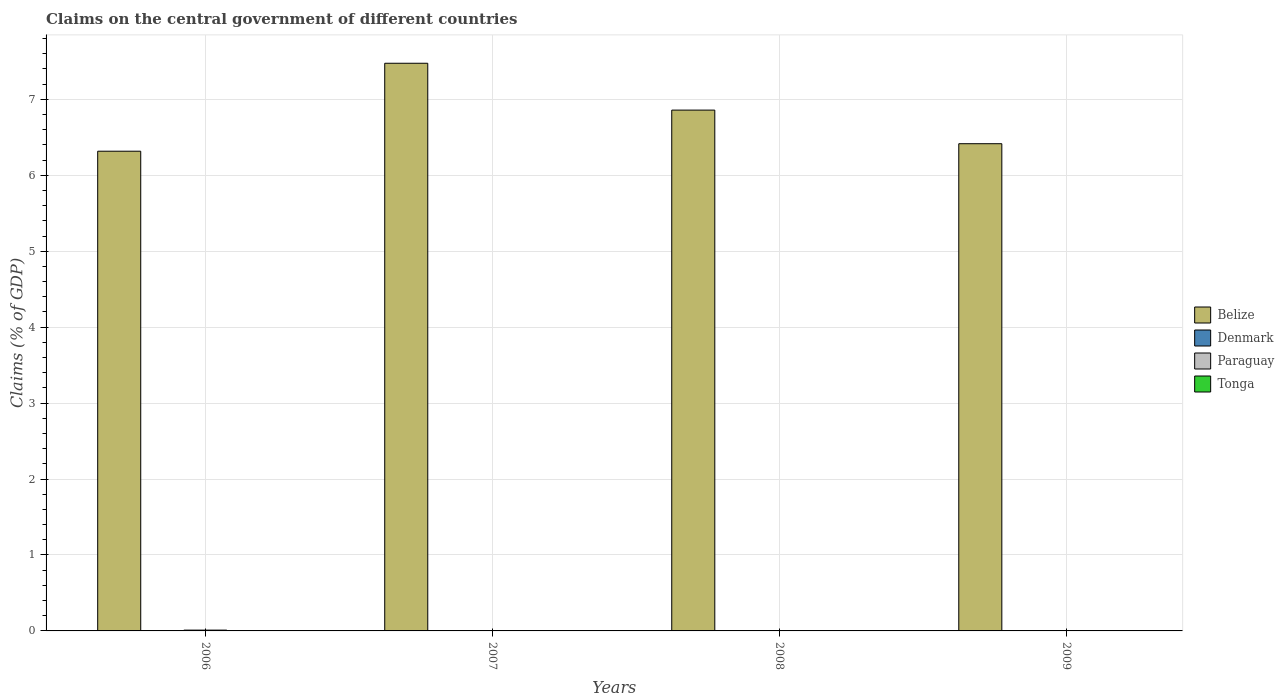Are the number of bars per tick equal to the number of legend labels?
Your answer should be compact. No. How many bars are there on the 3rd tick from the right?
Your answer should be very brief. 1. In how many cases, is the number of bars for a given year not equal to the number of legend labels?
Your answer should be very brief. 4. Across all years, what is the maximum percentage of GDP claimed on the central government in Paraguay?
Ensure brevity in your answer.  0.01. Across all years, what is the minimum percentage of GDP claimed on the central government in Belize?
Your response must be concise. 6.32. In which year was the percentage of GDP claimed on the central government in Paraguay maximum?
Your answer should be compact. 2006. What is the total percentage of GDP claimed on the central government in Belize in the graph?
Your response must be concise. 27.07. What is the difference between the percentage of GDP claimed on the central government in Belize in 2006 and that in 2008?
Your answer should be compact. -0.54. What is the difference between the percentage of GDP claimed on the central government in Denmark in 2008 and the percentage of GDP claimed on the central government in Belize in 2009?
Your answer should be compact. -6.42. What is the difference between the highest and the second highest percentage of GDP claimed on the central government in Belize?
Provide a succinct answer. 0.62. What is the difference between the highest and the lowest percentage of GDP claimed on the central government in Belize?
Your answer should be compact. 1.16. In how many years, is the percentage of GDP claimed on the central government in Tonga greater than the average percentage of GDP claimed on the central government in Tonga taken over all years?
Give a very brief answer. 0. Is it the case that in every year, the sum of the percentage of GDP claimed on the central government in Belize and percentage of GDP claimed on the central government in Paraguay is greater than the percentage of GDP claimed on the central government in Tonga?
Give a very brief answer. Yes. How many bars are there?
Your response must be concise. 5. How many years are there in the graph?
Give a very brief answer. 4. Are the values on the major ticks of Y-axis written in scientific E-notation?
Your response must be concise. No. Does the graph contain grids?
Your response must be concise. Yes. How are the legend labels stacked?
Offer a terse response. Vertical. What is the title of the graph?
Your answer should be very brief. Claims on the central government of different countries. What is the label or title of the Y-axis?
Your answer should be compact. Claims (% of GDP). What is the Claims (% of GDP) in Belize in 2006?
Your answer should be very brief. 6.32. What is the Claims (% of GDP) of Paraguay in 2006?
Offer a terse response. 0.01. What is the Claims (% of GDP) of Tonga in 2006?
Offer a very short reply. 0. What is the Claims (% of GDP) in Belize in 2007?
Offer a very short reply. 7.47. What is the Claims (% of GDP) in Denmark in 2007?
Ensure brevity in your answer.  0. What is the Claims (% of GDP) in Tonga in 2007?
Provide a short and direct response. 0. What is the Claims (% of GDP) of Belize in 2008?
Your answer should be very brief. 6.86. What is the Claims (% of GDP) of Paraguay in 2008?
Your response must be concise. 0. What is the Claims (% of GDP) in Belize in 2009?
Offer a very short reply. 6.42. What is the Claims (% of GDP) of Denmark in 2009?
Ensure brevity in your answer.  0. What is the Claims (% of GDP) in Tonga in 2009?
Give a very brief answer. 0. Across all years, what is the maximum Claims (% of GDP) of Belize?
Your answer should be very brief. 7.47. Across all years, what is the maximum Claims (% of GDP) of Paraguay?
Provide a short and direct response. 0.01. Across all years, what is the minimum Claims (% of GDP) of Belize?
Offer a very short reply. 6.32. What is the total Claims (% of GDP) of Belize in the graph?
Your answer should be very brief. 27.07. What is the total Claims (% of GDP) of Paraguay in the graph?
Offer a very short reply. 0.01. What is the total Claims (% of GDP) in Tonga in the graph?
Give a very brief answer. 0. What is the difference between the Claims (% of GDP) of Belize in 2006 and that in 2007?
Provide a succinct answer. -1.16. What is the difference between the Claims (% of GDP) in Belize in 2006 and that in 2008?
Your answer should be very brief. -0.54. What is the difference between the Claims (% of GDP) in Belize in 2006 and that in 2009?
Give a very brief answer. -0.1. What is the difference between the Claims (% of GDP) in Belize in 2007 and that in 2008?
Ensure brevity in your answer.  0.62. What is the difference between the Claims (% of GDP) in Belize in 2007 and that in 2009?
Make the answer very short. 1.06. What is the difference between the Claims (% of GDP) in Belize in 2008 and that in 2009?
Ensure brevity in your answer.  0.44. What is the average Claims (% of GDP) of Belize per year?
Ensure brevity in your answer.  6.77. What is the average Claims (% of GDP) of Paraguay per year?
Give a very brief answer. 0. What is the average Claims (% of GDP) of Tonga per year?
Offer a terse response. 0. In the year 2006, what is the difference between the Claims (% of GDP) in Belize and Claims (% of GDP) in Paraguay?
Offer a terse response. 6.31. What is the ratio of the Claims (% of GDP) in Belize in 2006 to that in 2007?
Make the answer very short. 0.85. What is the ratio of the Claims (% of GDP) of Belize in 2006 to that in 2008?
Give a very brief answer. 0.92. What is the ratio of the Claims (% of GDP) of Belize in 2006 to that in 2009?
Offer a terse response. 0.98. What is the ratio of the Claims (% of GDP) of Belize in 2007 to that in 2008?
Provide a short and direct response. 1.09. What is the ratio of the Claims (% of GDP) of Belize in 2007 to that in 2009?
Keep it short and to the point. 1.17. What is the ratio of the Claims (% of GDP) of Belize in 2008 to that in 2009?
Give a very brief answer. 1.07. What is the difference between the highest and the second highest Claims (% of GDP) in Belize?
Offer a very short reply. 0.62. What is the difference between the highest and the lowest Claims (% of GDP) of Belize?
Keep it short and to the point. 1.16. What is the difference between the highest and the lowest Claims (% of GDP) of Paraguay?
Make the answer very short. 0.01. 